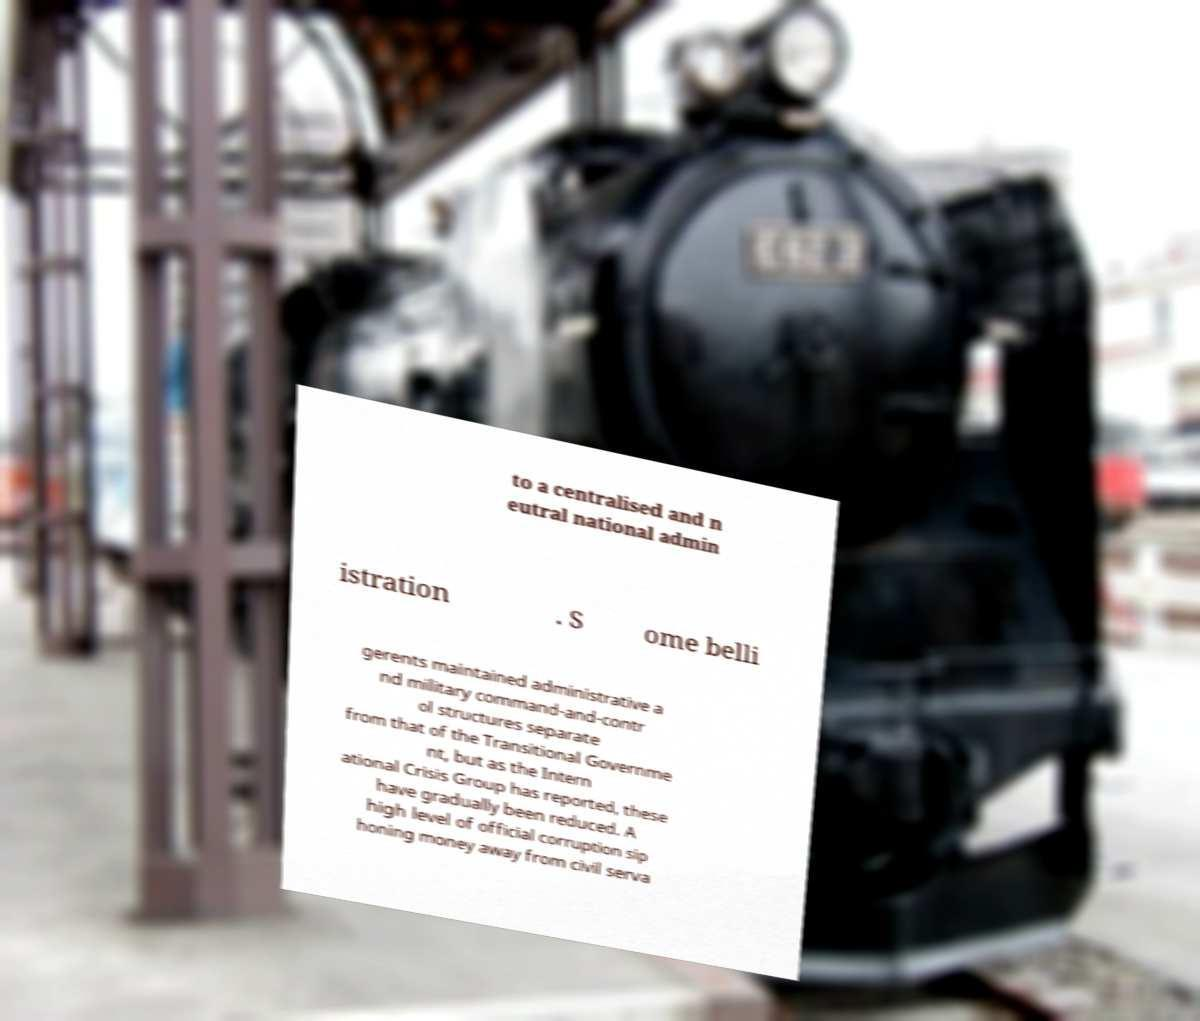What messages or text are displayed in this image? I need them in a readable, typed format. to a centralised and n eutral national admin istration . S ome belli gerents maintained administrative a nd military command-and-contr ol structures separate from that of the Transitional Governme nt, but as the Intern ational Crisis Group has reported, these have gradually been reduced. A high level of official corruption sip honing money away from civil serva 